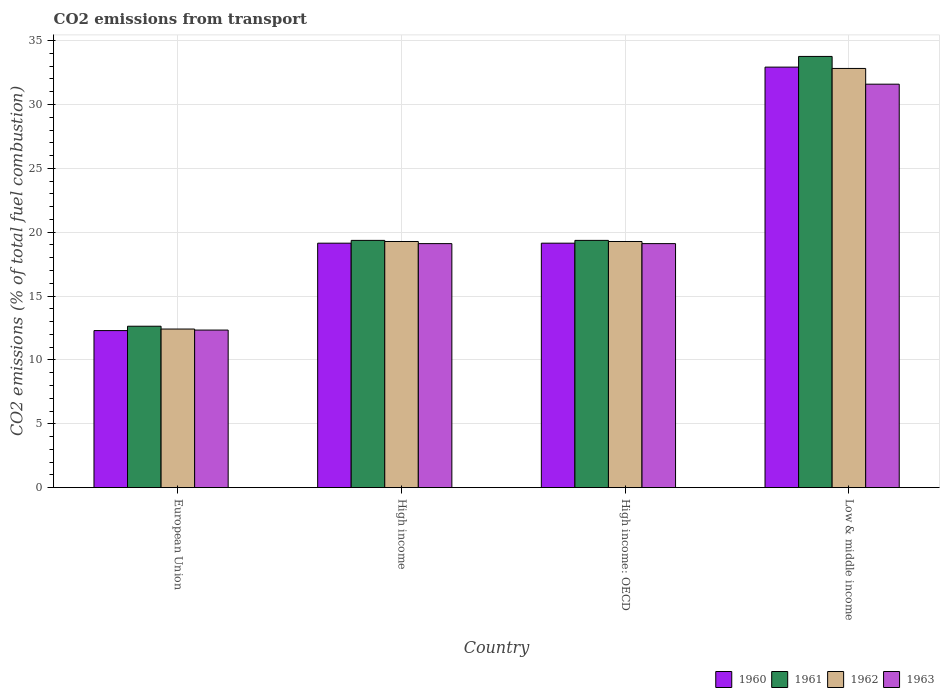How many different coloured bars are there?
Offer a very short reply. 4. Are the number of bars per tick equal to the number of legend labels?
Offer a terse response. Yes. Are the number of bars on each tick of the X-axis equal?
Your answer should be very brief. Yes. How many bars are there on the 3rd tick from the left?
Offer a terse response. 4. How many bars are there on the 3rd tick from the right?
Your answer should be very brief. 4. What is the total CO2 emitted in 1963 in Low & middle income?
Your response must be concise. 31.59. Across all countries, what is the maximum total CO2 emitted in 1963?
Provide a succinct answer. 31.59. Across all countries, what is the minimum total CO2 emitted in 1962?
Provide a short and direct response. 12.42. What is the total total CO2 emitted in 1961 in the graph?
Provide a short and direct response. 85.12. What is the difference between the total CO2 emitted in 1961 in European Union and that in High income?
Make the answer very short. -6.72. What is the difference between the total CO2 emitted in 1963 in High income and the total CO2 emitted in 1961 in High income: OECD?
Provide a succinct answer. -0.25. What is the average total CO2 emitted in 1961 per country?
Give a very brief answer. 21.28. What is the difference between the total CO2 emitted of/in 1963 and total CO2 emitted of/in 1961 in Low & middle income?
Provide a succinct answer. -2.17. What is the ratio of the total CO2 emitted in 1962 in European Union to that in Low & middle income?
Give a very brief answer. 0.38. Is the total CO2 emitted in 1961 in European Union less than that in High income: OECD?
Ensure brevity in your answer.  Yes. Is the difference between the total CO2 emitted in 1963 in High income: OECD and Low & middle income greater than the difference between the total CO2 emitted in 1961 in High income: OECD and Low & middle income?
Keep it short and to the point. Yes. What is the difference between the highest and the second highest total CO2 emitted in 1960?
Offer a very short reply. 13.79. What is the difference between the highest and the lowest total CO2 emitted in 1962?
Your response must be concise. 20.41. In how many countries, is the total CO2 emitted in 1962 greater than the average total CO2 emitted in 1962 taken over all countries?
Your answer should be very brief. 1. Is the sum of the total CO2 emitted in 1961 in High income and High income: OECD greater than the maximum total CO2 emitted in 1962 across all countries?
Offer a very short reply. Yes. What does the 4th bar from the right in High income: OECD represents?
Your answer should be compact. 1960. How many bars are there?
Offer a very short reply. 16. Are all the bars in the graph horizontal?
Provide a short and direct response. No. What is the difference between two consecutive major ticks on the Y-axis?
Your response must be concise. 5. Are the values on the major ticks of Y-axis written in scientific E-notation?
Provide a succinct answer. No. How many legend labels are there?
Offer a terse response. 4. How are the legend labels stacked?
Provide a short and direct response. Horizontal. What is the title of the graph?
Offer a terse response. CO2 emissions from transport. What is the label or title of the X-axis?
Keep it short and to the point. Country. What is the label or title of the Y-axis?
Your answer should be compact. CO2 emissions (% of total fuel combustion). What is the CO2 emissions (% of total fuel combustion) in 1960 in European Union?
Provide a succinct answer. 12.3. What is the CO2 emissions (% of total fuel combustion) of 1961 in European Union?
Your answer should be compact. 12.64. What is the CO2 emissions (% of total fuel combustion) in 1962 in European Union?
Your response must be concise. 12.42. What is the CO2 emissions (% of total fuel combustion) in 1963 in European Union?
Offer a terse response. 12.34. What is the CO2 emissions (% of total fuel combustion) of 1960 in High income?
Ensure brevity in your answer.  19.14. What is the CO2 emissions (% of total fuel combustion) in 1961 in High income?
Your answer should be compact. 19.36. What is the CO2 emissions (% of total fuel combustion) of 1962 in High income?
Your response must be concise. 19.27. What is the CO2 emissions (% of total fuel combustion) of 1963 in High income?
Give a very brief answer. 19.11. What is the CO2 emissions (% of total fuel combustion) of 1960 in High income: OECD?
Ensure brevity in your answer.  19.14. What is the CO2 emissions (% of total fuel combustion) of 1961 in High income: OECD?
Offer a very short reply. 19.36. What is the CO2 emissions (% of total fuel combustion) of 1962 in High income: OECD?
Offer a very short reply. 19.27. What is the CO2 emissions (% of total fuel combustion) of 1963 in High income: OECD?
Make the answer very short. 19.11. What is the CO2 emissions (% of total fuel combustion) of 1960 in Low & middle income?
Make the answer very short. 32.93. What is the CO2 emissions (% of total fuel combustion) in 1961 in Low & middle income?
Keep it short and to the point. 33.76. What is the CO2 emissions (% of total fuel combustion) in 1962 in Low & middle income?
Give a very brief answer. 32.82. What is the CO2 emissions (% of total fuel combustion) in 1963 in Low & middle income?
Keep it short and to the point. 31.59. Across all countries, what is the maximum CO2 emissions (% of total fuel combustion) of 1960?
Make the answer very short. 32.93. Across all countries, what is the maximum CO2 emissions (% of total fuel combustion) of 1961?
Your answer should be very brief. 33.76. Across all countries, what is the maximum CO2 emissions (% of total fuel combustion) in 1962?
Ensure brevity in your answer.  32.82. Across all countries, what is the maximum CO2 emissions (% of total fuel combustion) in 1963?
Make the answer very short. 31.59. Across all countries, what is the minimum CO2 emissions (% of total fuel combustion) in 1960?
Your answer should be very brief. 12.3. Across all countries, what is the minimum CO2 emissions (% of total fuel combustion) of 1961?
Provide a short and direct response. 12.64. Across all countries, what is the minimum CO2 emissions (% of total fuel combustion) in 1962?
Your answer should be very brief. 12.42. Across all countries, what is the minimum CO2 emissions (% of total fuel combustion) in 1963?
Ensure brevity in your answer.  12.34. What is the total CO2 emissions (% of total fuel combustion) in 1960 in the graph?
Make the answer very short. 83.51. What is the total CO2 emissions (% of total fuel combustion) of 1961 in the graph?
Your response must be concise. 85.12. What is the total CO2 emissions (% of total fuel combustion) in 1962 in the graph?
Your answer should be compact. 83.79. What is the total CO2 emissions (% of total fuel combustion) of 1963 in the graph?
Offer a very short reply. 82.14. What is the difference between the CO2 emissions (% of total fuel combustion) in 1960 in European Union and that in High income?
Ensure brevity in your answer.  -6.84. What is the difference between the CO2 emissions (% of total fuel combustion) of 1961 in European Union and that in High income?
Provide a succinct answer. -6.72. What is the difference between the CO2 emissions (% of total fuel combustion) of 1962 in European Union and that in High income?
Your answer should be compact. -6.86. What is the difference between the CO2 emissions (% of total fuel combustion) in 1963 in European Union and that in High income?
Provide a succinct answer. -6.77. What is the difference between the CO2 emissions (% of total fuel combustion) in 1960 in European Union and that in High income: OECD?
Provide a succinct answer. -6.84. What is the difference between the CO2 emissions (% of total fuel combustion) in 1961 in European Union and that in High income: OECD?
Ensure brevity in your answer.  -6.72. What is the difference between the CO2 emissions (% of total fuel combustion) of 1962 in European Union and that in High income: OECD?
Your response must be concise. -6.86. What is the difference between the CO2 emissions (% of total fuel combustion) of 1963 in European Union and that in High income: OECD?
Your answer should be very brief. -6.77. What is the difference between the CO2 emissions (% of total fuel combustion) in 1960 in European Union and that in Low & middle income?
Make the answer very short. -20.63. What is the difference between the CO2 emissions (% of total fuel combustion) of 1961 in European Union and that in Low & middle income?
Offer a very short reply. -21.13. What is the difference between the CO2 emissions (% of total fuel combustion) of 1962 in European Union and that in Low & middle income?
Keep it short and to the point. -20.41. What is the difference between the CO2 emissions (% of total fuel combustion) of 1963 in European Union and that in Low & middle income?
Your response must be concise. -19.25. What is the difference between the CO2 emissions (% of total fuel combustion) in 1962 in High income and that in High income: OECD?
Your answer should be compact. 0. What is the difference between the CO2 emissions (% of total fuel combustion) of 1960 in High income and that in Low & middle income?
Keep it short and to the point. -13.79. What is the difference between the CO2 emissions (% of total fuel combustion) of 1961 in High income and that in Low & middle income?
Your response must be concise. -14.4. What is the difference between the CO2 emissions (% of total fuel combustion) in 1962 in High income and that in Low & middle income?
Offer a terse response. -13.55. What is the difference between the CO2 emissions (% of total fuel combustion) of 1963 in High income and that in Low & middle income?
Your response must be concise. -12.48. What is the difference between the CO2 emissions (% of total fuel combustion) of 1960 in High income: OECD and that in Low & middle income?
Provide a short and direct response. -13.79. What is the difference between the CO2 emissions (% of total fuel combustion) of 1961 in High income: OECD and that in Low & middle income?
Ensure brevity in your answer.  -14.4. What is the difference between the CO2 emissions (% of total fuel combustion) of 1962 in High income: OECD and that in Low & middle income?
Keep it short and to the point. -13.55. What is the difference between the CO2 emissions (% of total fuel combustion) in 1963 in High income: OECD and that in Low & middle income?
Your answer should be compact. -12.48. What is the difference between the CO2 emissions (% of total fuel combustion) of 1960 in European Union and the CO2 emissions (% of total fuel combustion) of 1961 in High income?
Ensure brevity in your answer.  -7.06. What is the difference between the CO2 emissions (% of total fuel combustion) of 1960 in European Union and the CO2 emissions (% of total fuel combustion) of 1962 in High income?
Offer a very short reply. -6.98. What is the difference between the CO2 emissions (% of total fuel combustion) in 1960 in European Union and the CO2 emissions (% of total fuel combustion) in 1963 in High income?
Provide a short and direct response. -6.81. What is the difference between the CO2 emissions (% of total fuel combustion) in 1961 in European Union and the CO2 emissions (% of total fuel combustion) in 1962 in High income?
Your answer should be compact. -6.64. What is the difference between the CO2 emissions (% of total fuel combustion) of 1961 in European Union and the CO2 emissions (% of total fuel combustion) of 1963 in High income?
Provide a succinct answer. -6.47. What is the difference between the CO2 emissions (% of total fuel combustion) of 1962 in European Union and the CO2 emissions (% of total fuel combustion) of 1963 in High income?
Keep it short and to the point. -6.69. What is the difference between the CO2 emissions (% of total fuel combustion) of 1960 in European Union and the CO2 emissions (% of total fuel combustion) of 1961 in High income: OECD?
Make the answer very short. -7.06. What is the difference between the CO2 emissions (% of total fuel combustion) in 1960 in European Union and the CO2 emissions (% of total fuel combustion) in 1962 in High income: OECD?
Make the answer very short. -6.98. What is the difference between the CO2 emissions (% of total fuel combustion) in 1960 in European Union and the CO2 emissions (% of total fuel combustion) in 1963 in High income: OECD?
Keep it short and to the point. -6.81. What is the difference between the CO2 emissions (% of total fuel combustion) in 1961 in European Union and the CO2 emissions (% of total fuel combustion) in 1962 in High income: OECD?
Your answer should be compact. -6.64. What is the difference between the CO2 emissions (% of total fuel combustion) in 1961 in European Union and the CO2 emissions (% of total fuel combustion) in 1963 in High income: OECD?
Offer a terse response. -6.47. What is the difference between the CO2 emissions (% of total fuel combustion) of 1962 in European Union and the CO2 emissions (% of total fuel combustion) of 1963 in High income: OECD?
Your answer should be compact. -6.69. What is the difference between the CO2 emissions (% of total fuel combustion) of 1960 in European Union and the CO2 emissions (% of total fuel combustion) of 1961 in Low & middle income?
Keep it short and to the point. -21.47. What is the difference between the CO2 emissions (% of total fuel combustion) of 1960 in European Union and the CO2 emissions (% of total fuel combustion) of 1962 in Low & middle income?
Provide a succinct answer. -20.53. What is the difference between the CO2 emissions (% of total fuel combustion) in 1960 in European Union and the CO2 emissions (% of total fuel combustion) in 1963 in Low & middle income?
Ensure brevity in your answer.  -19.29. What is the difference between the CO2 emissions (% of total fuel combustion) in 1961 in European Union and the CO2 emissions (% of total fuel combustion) in 1962 in Low & middle income?
Keep it short and to the point. -20.19. What is the difference between the CO2 emissions (% of total fuel combustion) of 1961 in European Union and the CO2 emissions (% of total fuel combustion) of 1963 in Low & middle income?
Offer a terse response. -18.95. What is the difference between the CO2 emissions (% of total fuel combustion) of 1962 in European Union and the CO2 emissions (% of total fuel combustion) of 1963 in Low & middle income?
Offer a very short reply. -19.17. What is the difference between the CO2 emissions (% of total fuel combustion) of 1960 in High income and the CO2 emissions (% of total fuel combustion) of 1961 in High income: OECD?
Offer a terse response. -0.22. What is the difference between the CO2 emissions (% of total fuel combustion) of 1960 in High income and the CO2 emissions (% of total fuel combustion) of 1962 in High income: OECD?
Offer a terse response. -0.13. What is the difference between the CO2 emissions (% of total fuel combustion) in 1960 in High income and the CO2 emissions (% of total fuel combustion) in 1963 in High income: OECD?
Ensure brevity in your answer.  0.03. What is the difference between the CO2 emissions (% of total fuel combustion) of 1961 in High income and the CO2 emissions (% of total fuel combustion) of 1962 in High income: OECD?
Your answer should be compact. 0.09. What is the difference between the CO2 emissions (% of total fuel combustion) in 1961 in High income and the CO2 emissions (% of total fuel combustion) in 1963 in High income: OECD?
Ensure brevity in your answer.  0.25. What is the difference between the CO2 emissions (% of total fuel combustion) of 1962 in High income and the CO2 emissions (% of total fuel combustion) of 1963 in High income: OECD?
Provide a succinct answer. 0.17. What is the difference between the CO2 emissions (% of total fuel combustion) of 1960 in High income and the CO2 emissions (% of total fuel combustion) of 1961 in Low & middle income?
Provide a short and direct response. -14.62. What is the difference between the CO2 emissions (% of total fuel combustion) in 1960 in High income and the CO2 emissions (% of total fuel combustion) in 1962 in Low & middle income?
Make the answer very short. -13.68. What is the difference between the CO2 emissions (% of total fuel combustion) in 1960 in High income and the CO2 emissions (% of total fuel combustion) in 1963 in Low & middle income?
Your answer should be very brief. -12.45. What is the difference between the CO2 emissions (% of total fuel combustion) of 1961 in High income and the CO2 emissions (% of total fuel combustion) of 1962 in Low & middle income?
Your response must be concise. -13.46. What is the difference between the CO2 emissions (% of total fuel combustion) of 1961 in High income and the CO2 emissions (% of total fuel combustion) of 1963 in Low & middle income?
Your answer should be very brief. -12.23. What is the difference between the CO2 emissions (% of total fuel combustion) of 1962 in High income and the CO2 emissions (% of total fuel combustion) of 1963 in Low & middle income?
Keep it short and to the point. -12.32. What is the difference between the CO2 emissions (% of total fuel combustion) of 1960 in High income: OECD and the CO2 emissions (% of total fuel combustion) of 1961 in Low & middle income?
Make the answer very short. -14.62. What is the difference between the CO2 emissions (% of total fuel combustion) in 1960 in High income: OECD and the CO2 emissions (% of total fuel combustion) in 1962 in Low & middle income?
Ensure brevity in your answer.  -13.68. What is the difference between the CO2 emissions (% of total fuel combustion) of 1960 in High income: OECD and the CO2 emissions (% of total fuel combustion) of 1963 in Low & middle income?
Provide a short and direct response. -12.45. What is the difference between the CO2 emissions (% of total fuel combustion) of 1961 in High income: OECD and the CO2 emissions (% of total fuel combustion) of 1962 in Low & middle income?
Your answer should be compact. -13.46. What is the difference between the CO2 emissions (% of total fuel combustion) in 1961 in High income: OECD and the CO2 emissions (% of total fuel combustion) in 1963 in Low & middle income?
Your answer should be compact. -12.23. What is the difference between the CO2 emissions (% of total fuel combustion) in 1962 in High income: OECD and the CO2 emissions (% of total fuel combustion) in 1963 in Low & middle income?
Your response must be concise. -12.32. What is the average CO2 emissions (% of total fuel combustion) in 1960 per country?
Make the answer very short. 20.88. What is the average CO2 emissions (% of total fuel combustion) in 1961 per country?
Make the answer very short. 21.28. What is the average CO2 emissions (% of total fuel combustion) of 1962 per country?
Keep it short and to the point. 20.95. What is the average CO2 emissions (% of total fuel combustion) of 1963 per country?
Provide a succinct answer. 20.54. What is the difference between the CO2 emissions (% of total fuel combustion) in 1960 and CO2 emissions (% of total fuel combustion) in 1961 in European Union?
Your answer should be compact. -0.34. What is the difference between the CO2 emissions (% of total fuel combustion) in 1960 and CO2 emissions (% of total fuel combustion) in 1962 in European Union?
Keep it short and to the point. -0.12. What is the difference between the CO2 emissions (% of total fuel combustion) in 1960 and CO2 emissions (% of total fuel combustion) in 1963 in European Union?
Offer a very short reply. -0.04. What is the difference between the CO2 emissions (% of total fuel combustion) in 1961 and CO2 emissions (% of total fuel combustion) in 1962 in European Union?
Provide a succinct answer. 0.22. What is the difference between the CO2 emissions (% of total fuel combustion) of 1961 and CO2 emissions (% of total fuel combustion) of 1963 in European Union?
Provide a short and direct response. 0.3. What is the difference between the CO2 emissions (% of total fuel combustion) of 1962 and CO2 emissions (% of total fuel combustion) of 1963 in European Union?
Your answer should be compact. 0.08. What is the difference between the CO2 emissions (% of total fuel combustion) in 1960 and CO2 emissions (% of total fuel combustion) in 1961 in High income?
Ensure brevity in your answer.  -0.22. What is the difference between the CO2 emissions (% of total fuel combustion) in 1960 and CO2 emissions (% of total fuel combustion) in 1962 in High income?
Offer a terse response. -0.13. What is the difference between the CO2 emissions (% of total fuel combustion) of 1960 and CO2 emissions (% of total fuel combustion) of 1963 in High income?
Offer a terse response. 0.03. What is the difference between the CO2 emissions (% of total fuel combustion) in 1961 and CO2 emissions (% of total fuel combustion) in 1962 in High income?
Your response must be concise. 0.09. What is the difference between the CO2 emissions (% of total fuel combustion) in 1961 and CO2 emissions (% of total fuel combustion) in 1963 in High income?
Ensure brevity in your answer.  0.25. What is the difference between the CO2 emissions (% of total fuel combustion) in 1962 and CO2 emissions (% of total fuel combustion) in 1963 in High income?
Your response must be concise. 0.17. What is the difference between the CO2 emissions (% of total fuel combustion) of 1960 and CO2 emissions (% of total fuel combustion) of 1961 in High income: OECD?
Your response must be concise. -0.22. What is the difference between the CO2 emissions (% of total fuel combustion) of 1960 and CO2 emissions (% of total fuel combustion) of 1962 in High income: OECD?
Offer a very short reply. -0.13. What is the difference between the CO2 emissions (% of total fuel combustion) in 1960 and CO2 emissions (% of total fuel combustion) in 1963 in High income: OECD?
Your answer should be very brief. 0.03. What is the difference between the CO2 emissions (% of total fuel combustion) of 1961 and CO2 emissions (% of total fuel combustion) of 1962 in High income: OECD?
Give a very brief answer. 0.09. What is the difference between the CO2 emissions (% of total fuel combustion) of 1961 and CO2 emissions (% of total fuel combustion) of 1963 in High income: OECD?
Ensure brevity in your answer.  0.25. What is the difference between the CO2 emissions (% of total fuel combustion) in 1962 and CO2 emissions (% of total fuel combustion) in 1963 in High income: OECD?
Your answer should be compact. 0.17. What is the difference between the CO2 emissions (% of total fuel combustion) in 1960 and CO2 emissions (% of total fuel combustion) in 1961 in Low & middle income?
Your response must be concise. -0.84. What is the difference between the CO2 emissions (% of total fuel combustion) in 1960 and CO2 emissions (% of total fuel combustion) in 1962 in Low & middle income?
Provide a short and direct response. 0.1. What is the difference between the CO2 emissions (% of total fuel combustion) of 1960 and CO2 emissions (% of total fuel combustion) of 1963 in Low & middle income?
Offer a very short reply. 1.34. What is the difference between the CO2 emissions (% of total fuel combustion) in 1961 and CO2 emissions (% of total fuel combustion) in 1962 in Low & middle income?
Your answer should be very brief. 0.94. What is the difference between the CO2 emissions (% of total fuel combustion) in 1961 and CO2 emissions (% of total fuel combustion) in 1963 in Low & middle income?
Ensure brevity in your answer.  2.17. What is the difference between the CO2 emissions (% of total fuel combustion) in 1962 and CO2 emissions (% of total fuel combustion) in 1963 in Low & middle income?
Keep it short and to the point. 1.23. What is the ratio of the CO2 emissions (% of total fuel combustion) in 1960 in European Union to that in High income?
Give a very brief answer. 0.64. What is the ratio of the CO2 emissions (% of total fuel combustion) of 1961 in European Union to that in High income?
Give a very brief answer. 0.65. What is the ratio of the CO2 emissions (% of total fuel combustion) in 1962 in European Union to that in High income?
Your answer should be compact. 0.64. What is the ratio of the CO2 emissions (% of total fuel combustion) of 1963 in European Union to that in High income?
Offer a terse response. 0.65. What is the ratio of the CO2 emissions (% of total fuel combustion) of 1960 in European Union to that in High income: OECD?
Offer a very short reply. 0.64. What is the ratio of the CO2 emissions (% of total fuel combustion) of 1961 in European Union to that in High income: OECD?
Give a very brief answer. 0.65. What is the ratio of the CO2 emissions (% of total fuel combustion) in 1962 in European Union to that in High income: OECD?
Offer a very short reply. 0.64. What is the ratio of the CO2 emissions (% of total fuel combustion) of 1963 in European Union to that in High income: OECD?
Provide a short and direct response. 0.65. What is the ratio of the CO2 emissions (% of total fuel combustion) in 1960 in European Union to that in Low & middle income?
Offer a very short reply. 0.37. What is the ratio of the CO2 emissions (% of total fuel combustion) of 1961 in European Union to that in Low & middle income?
Offer a very short reply. 0.37. What is the ratio of the CO2 emissions (% of total fuel combustion) in 1962 in European Union to that in Low & middle income?
Your answer should be compact. 0.38. What is the ratio of the CO2 emissions (% of total fuel combustion) of 1963 in European Union to that in Low & middle income?
Make the answer very short. 0.39. What is the ratio of the CO2 emissions (% of total fuel combustion) of 1960 in High income to that in High income: OECD?
Give a very brief answer. 1. What is the ratio of the CO2 emissions (% of total fuel combustion) of 1960 in High income to that in Low & middle income?
Your answer should be compact. 0.58. What is the ratio of the CO2 emissions (% of total fuel combustion) of 1961 in High income to that in Low & middle income?
Provide a short and direct response. 0.57. What is the ratio of the CO2 emissions (% of total fuel combustion) of 1962 in High income to that in Low & middle income?
Give a very brief answer. 0.59. What is the ratio of the CO2 emissions (% of total fuel combustion) of 1963 in High income to that in Low & middle income?
Offer a terse response. 0.6. What is the ratio of the CO2 emissions (% of total fuel combustion) in 1960 in High income: OECD to that in Low & middle income?
Keep it short and to the point. 0.58. What is the ratio of the CO2 emissions (% of total fuel combustion) in 1961 in High income: OECD to that in Low & middle income?
Your answer should be compact. 0.57. What is the ratio of the CO2 emissions (% of total fuel combustion) in 1962 in High income: OECD to that in Low & middle income?
Keep it short and to the point. 0.59. What is the ratio of the CO2 emissions (% of total fuel combustion) of 1963 in High income: OECD to that in Low & middle income?
Your answer should be very brief. 0.6. What is the difference between the highest and the second highest CO2 emissions (% of total fuel combustion) in 1960?
Make the answer very short. 13.79. What is the difference between the highest and the second highest CO2 emissions (% of total fuel combustion) in 1961?
Offer a very short reply. 14.4. What is the difference between the highest and the second highest CO2 emissions (% of total fuel combustion) of 1962?
Your answer should be compact. 13.55. What is the difference between the highest and the second highest CO2 emissions (% of total fuel combustion) of 1963?
Offer a very short reply. 12.48. What is the difference between the highest and the lowest CO2 emissions (% of total fuel combustion) of 1960?
Offer a terse response. 20.63. What is the difference between the highest and the lowest CO2 emissions (% of total fuel combustion) in 1961?
Your response must be concise. 21.13. What is the difference between the highest and the lowest CO2 emissions (% of total fuel combustion) in 1962?
Offer a very short reply. 20.41. What is the difference between the highest and the lowest CO2 emissions (% of total fuel combustion) in 1963?
Your answer should be compact. 19.25. 